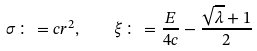Convert formula to latex. <formula><loc_0><loc_0><loc_500><loc_500>\sigma \colon = c r ^ { 2 } , \quad \xi \colon = \frac { E } { 4 c } - \frac { \sqrt { \lambda } + 1 } { 2 }</formula> 